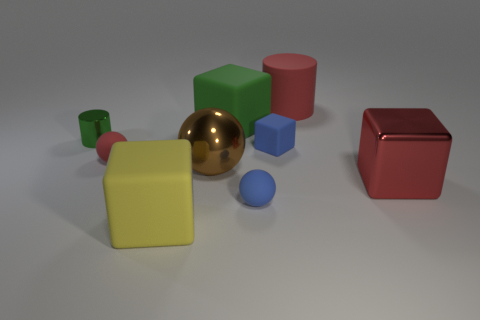Subtract all blue matte balls. How many balls are left? 2 Subtract 2 cubes. How many cubes are left? 2 Add 1 tiny red matte things. How many objects exist? 10 Subtract all blue blocks. How many blocks are left? 3 Subtract all spheres. How many objects are left? 6 Subtract all brown blocks. Subtract all brown cylinders. How many blocks are left? 4 Add 3 small red rubber spheres. How many small red rubber spheres are left? 4 Add 9 small green metallic balls. How many small green metallic balls exist? 9 Subtract 0 gray spheres. How many objects are left? 9 Subtract all big balls. Subtract all big brown shiny cylinders. How many objects are left? 8 